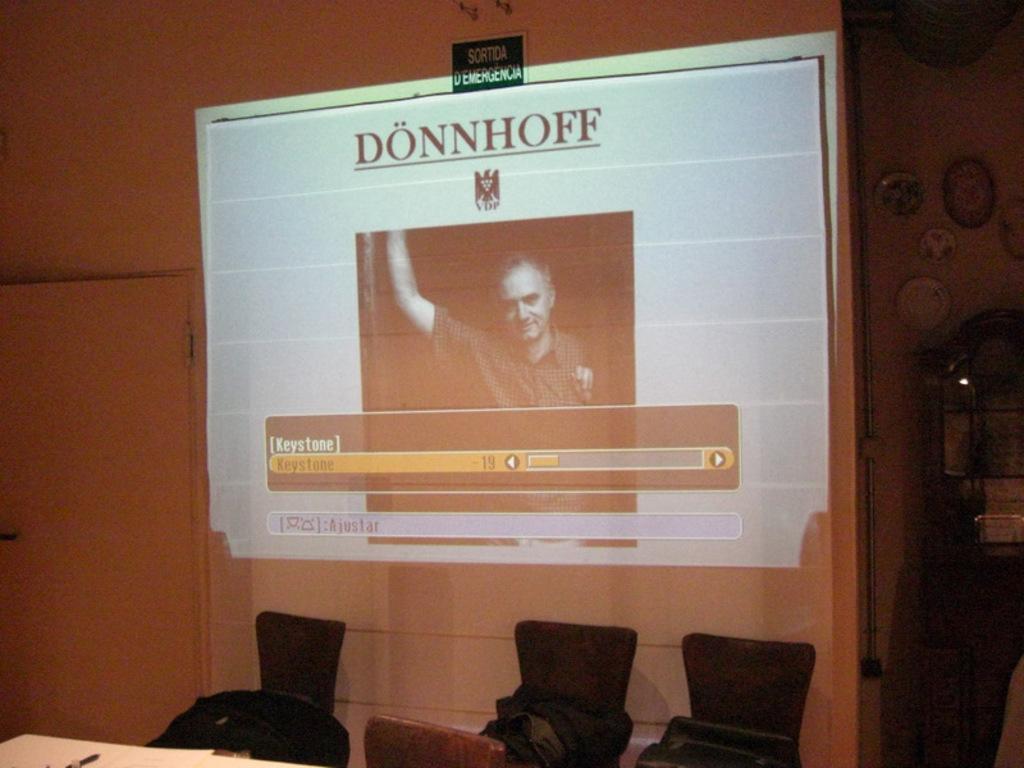Can you describe this image briefly? This image is taken indoors. At the bottom of the image there is a table with a few things on it and there are a few empty chairs. In the background there is a wall with a projector screen and a door. On the right side of the image there are a few picture frames on the wall. 